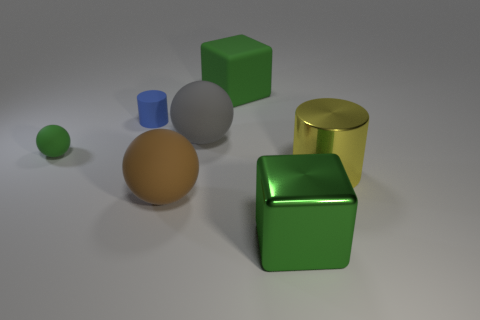Add 1 large brown objects. How many objects exist? 8 Subtract all big balls. How many balls are left? 1 Subtract all gray spheres. How many spheres are left? 2 Subtract all cylinders. How many objects are left? 5 Subtract 1 spheres. How many spheres are left? 2 Subtract all purple spheres. Subtract all cyan cylinders. How many spheres are left? 3 Subtract all red balls. How many yellow cylinders are left? 1 Subtract all big spheres. Subtract all brown things. How many objects are left? 4 Add 2 tiny green balls. How many tiny green balls are left? 3 Add 5 large yellow shiny balls. How many large yellow shiny balls exist? 5 